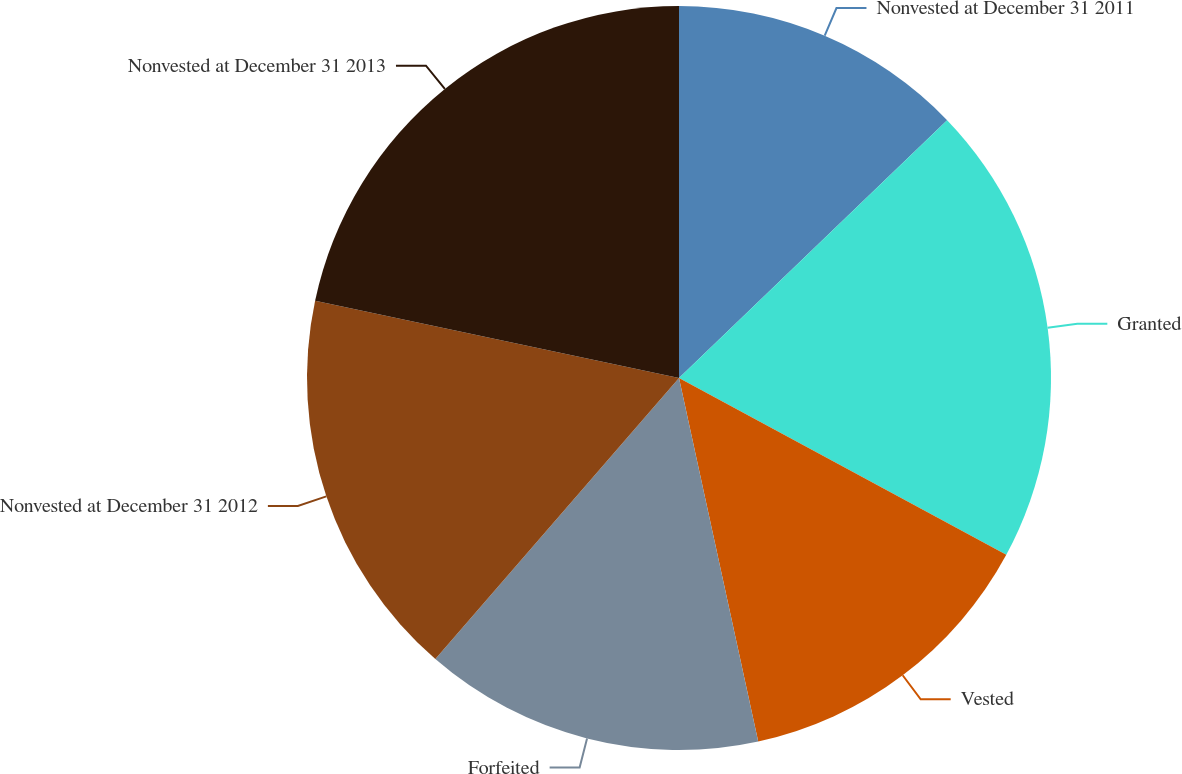<chart> <loc_0><loc_0><loc_500><loc_500><pie_chart><fcel>Nonvested at December 31 2011<fcel>Granted<fcel>Vested<fcel>Forfeited<fcel>Nonvested at December 31 2012<fcel>Nonvested at December 31 2013<nl><fcel>12.81%<fcel>20.07%<fcel>13.7%<fcel>14.78%<fcel>16.96%<fcel>21.67%<nl></chart> 